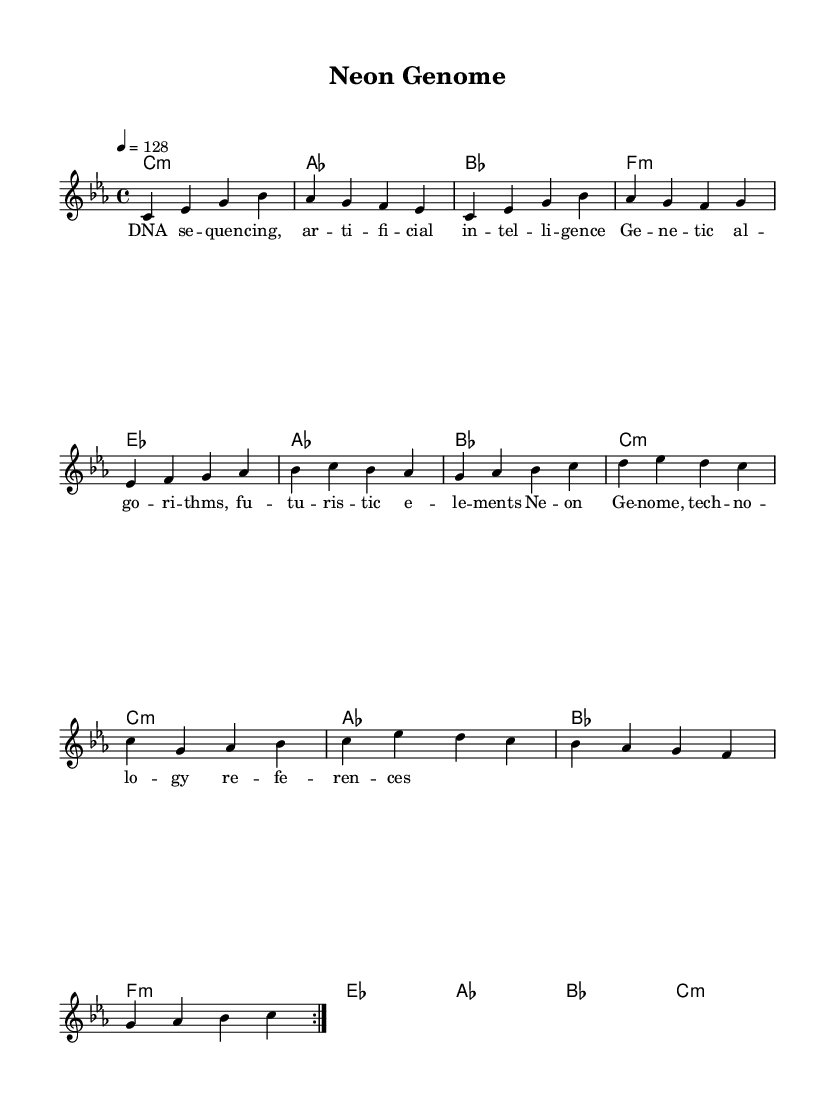What is the key signature of this music? The key signature in the piece is indicated by the absence of sharps or flats, suggesting it is in C minor as implied by the global context settings.
Answer: C minor What is the time signature of this music? The time signature appears at the beginning of the score as 4/4, which means there are four beats per measure and a quarter note gets one beat.
Answer: 4/4 What is the tempo marking used in this music? The tempo is specified at the beginning with the marking indicating a speed of 128 beats per minute (quarter note = 128), guiding the overall pace of the piece.
Answer: 128 How many times is the verse repeated in this piece? The repetition of the verse section is indicated by the notation "\repeat volta 2", meaning it is played two times in total.
Answer: 2 Which musical mode is predominantly used in the chorus section? The chorus section primarily utilizes the C minor chord (as indicated by the harmonies), which reflects the tonal quality of the piece focusing on the minor mode.
Answer: C minor What theme do the lyrics in this music revolve around? The lyrics reference concepts related to technology and genetics, highlighting elements such as artificial intelligence, genetic algorithms, and futuristic elements, consistent with the K-Pop genre's inclination towards modern themes.
Answer: Technology and genetics What is the harmonic structure used during the pre-chorus? The pre-chorus harmonic pattern is defined through chords including E-flat major, A-flat major, B-flat major, and C minor as shown in the harmony section, depicting a progression typical for building up to a chorus.
Answer: E-flat major, A-flat major, B-flat major, C minor 